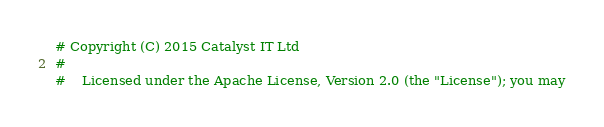<code> <loc_0><loc_0><loc_500><loc_500><_Python_># Copyright (C) 2015 Catalyst IT Ltd
#
#    Licensed under the Apache License, Version 2.0 (the "License"); you may</code> 